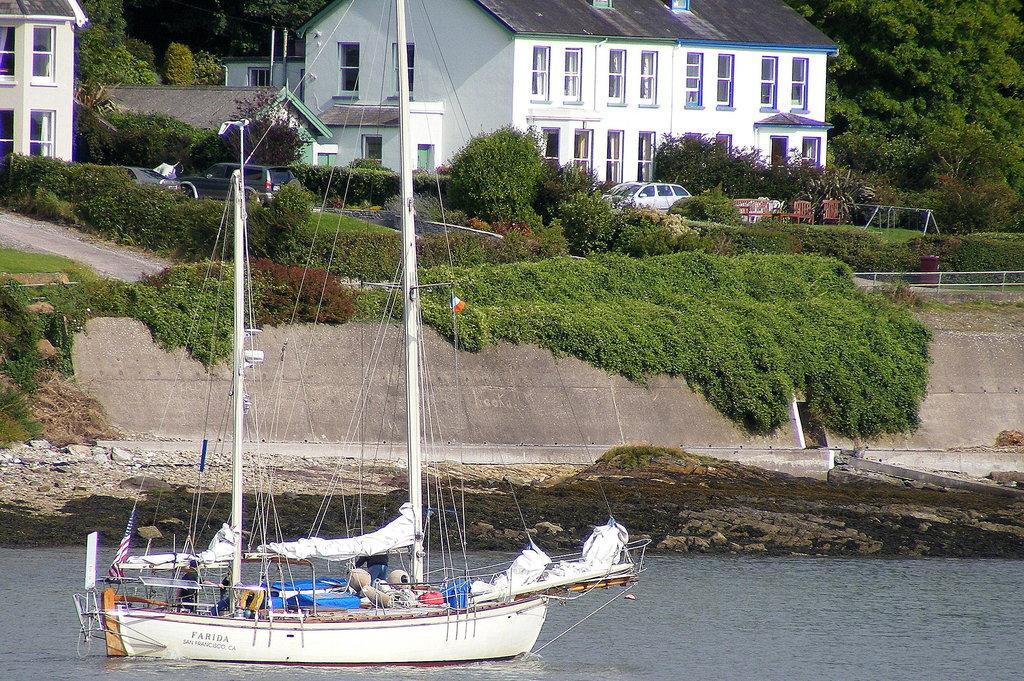Please provide a concise description of this image. At the bottom of this image, there is a boat on the water. In the background, there are buildings, trees, plants, vehicles, chairs and grass on the ground. 